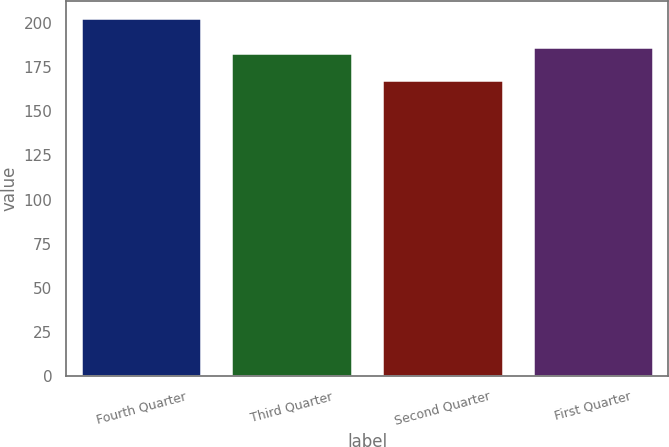Convert chart to OTSL. <chart><loc_0><loc_0><loc_500><loc_500><bar_chart><fcel>Fourth Quarter<fcel>Third Quarter<fcel>Second Quarter<fcel>First Quarter<nl><fcel>202.5<fcel>182.9<fcel>167.6<fcel>186.39<nl></chart> 